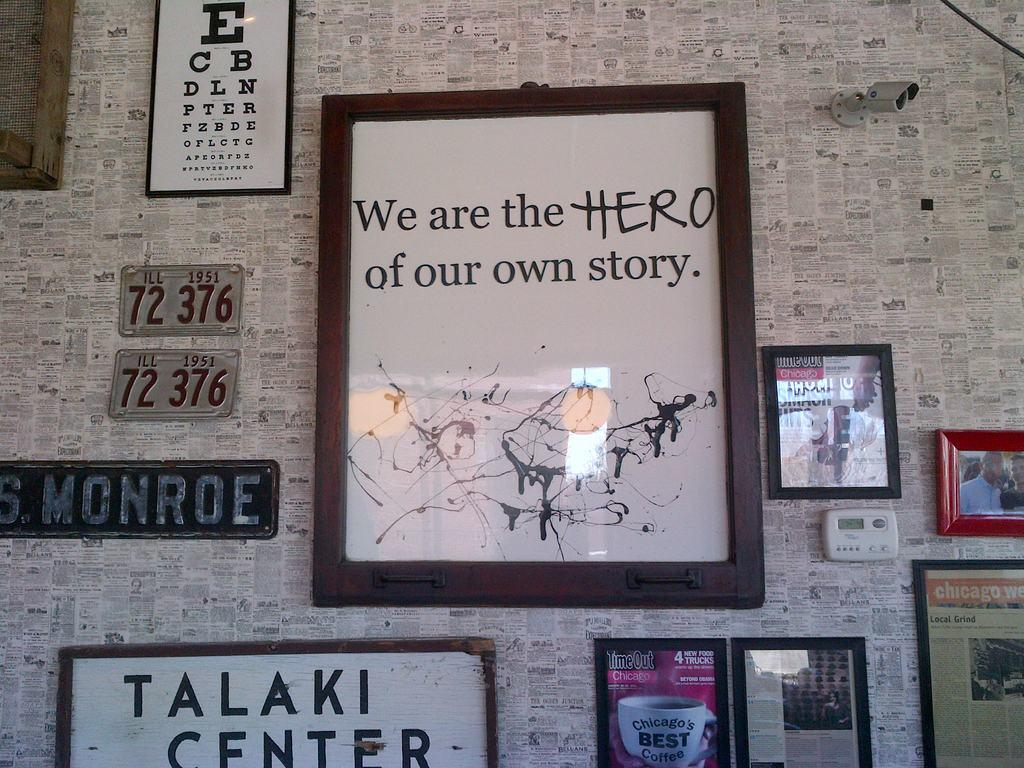<image>
Give a short and clear explanation of the subsequent image. A wall is wallpapered with a newspaper print with random frames hanging from the wall including a 1951 license plate from Illinois. 